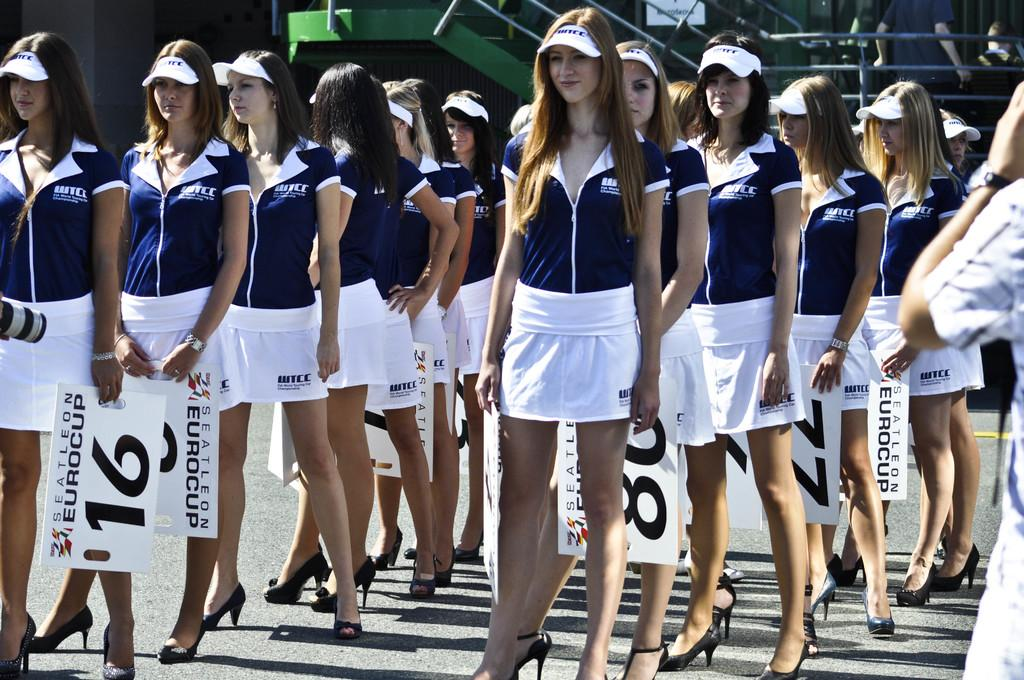<image>
Render a clear and concise summary of the photo. Women in blue shirts and white skirts stand in rows holding signs that say SEATTLEON EUROCUP. 